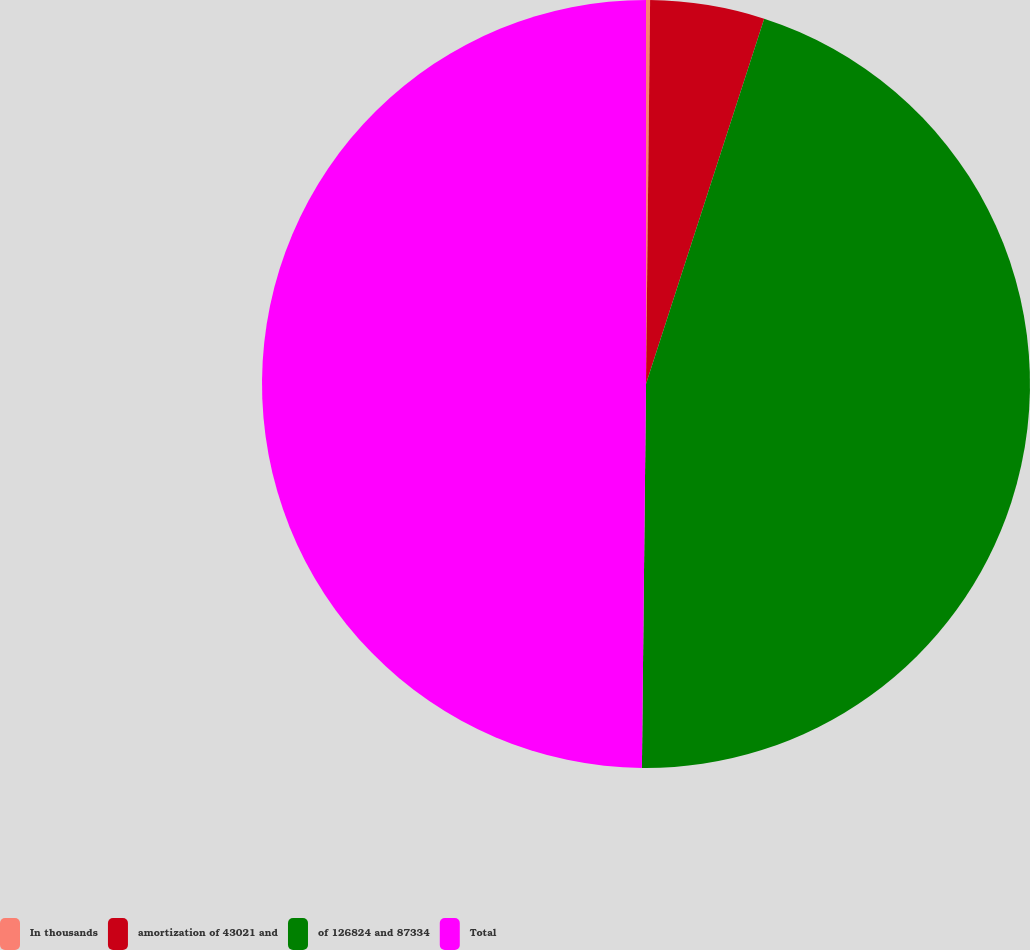<chart> <loc_0><loc_0><loc_500><loc_500><pie_chart><fcel>In thousands<fcel>amortization of 43021 and<fcel>of 126824 and 87334<fcel>Total<nl><fcel>0.17%<fcel>4.81%<fcel>45.19%<fcel>49.83%<nl></chart> 